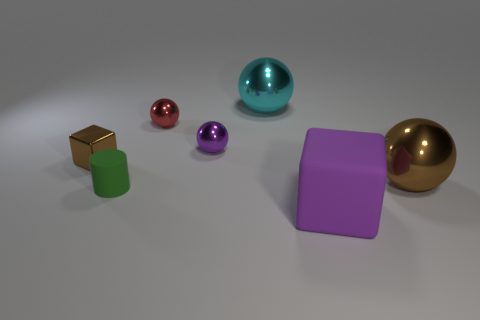Subtract all red metallic spheres. How many spheres are left? 3 Add 2 purple blocks. How many objects exist? 9 Subtract all purple blocks. How many blocks are left? 1 Subtract all balls. How many objects are left? 3 Subtract 1 cubes. How many cubes are left? 1 Subtract all red cylinders. Subtract all red spheres. How many cylinders are left? 1 Subtract all big cyan metallic balls. Subtract all green objects. How many objects are left? 5 Add 7 tiny purple shiny balls. How many tiny purple shiny balls are left? 8 Add 3 small yellow metal cubes. How many small yellow metal cubes exist? 3 Subtract 0 brown cylinders. How many objects are left? 7 